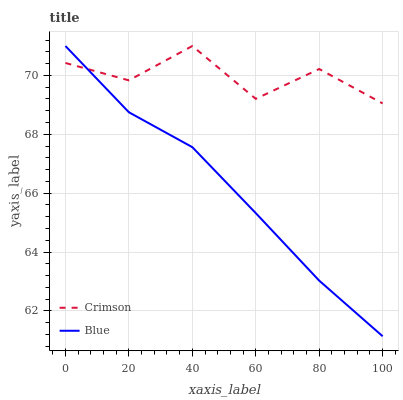Does Blue have the minimum area under the curve?
Answer yes or no. Yes. Does Crimson have the maximum area under the curve?
Answer yes or no. Yes. Does Blue have the maximum area under the curve?
Answer yes or no. No. Is Blue the smoothest?
Answer yes or no. Yes. Is Crimson the roughest?
Answer yes or no. Yes. Is Blue the roughest?
Answer yes or no. No. 